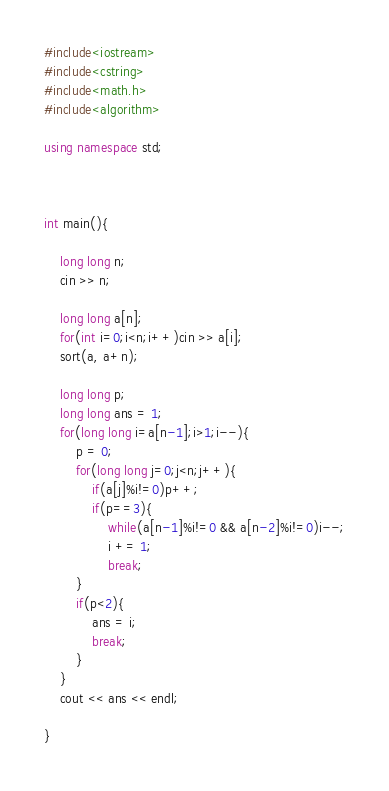Convert code to text. <code><loc_0><loc_0><loc_500><loc_500><_C++_>#include<iostream>
#include<cstring>
#include<math.h>
#include<algorithm>

using namespace std;



int main(){

    long long n;
    cin >> n;

    long long a[n];
    for(int i=0;i<n;i++)cin >> a[i];
    sort(a, a+n);

    long long p;
    long long ans = 1;
    for(long long i=a[n-1];i>1;i--){
        p = 0;
        for(long long j=0;j<n;j++){
            if(a[j]%i!=0)p++;
            if(p==3){
                while(a[n-1]%i!=0 && a[n-2]%i!=0)i--;
                i += 1;
                break;
        }
        if(p<2){
            ans = i;
            break;
        }
    }
    cout << ans << endl;

}
</code> 